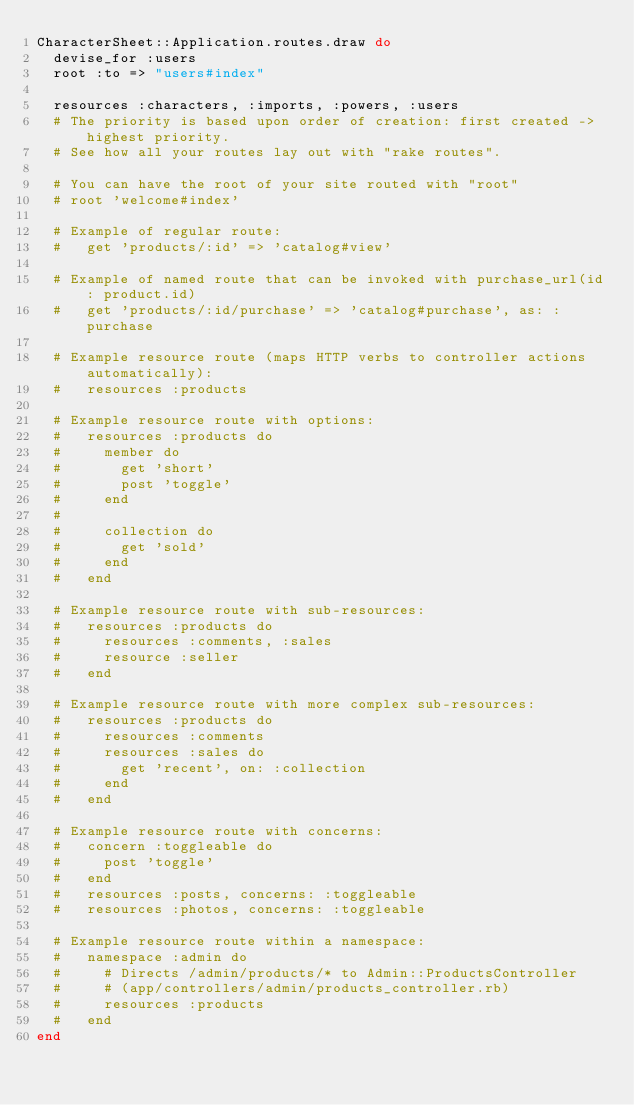Convert code to text. <code><loc_0><loc_0><loc_500><loc_500><_Ruby_>CharacterSheet::Application.routes.draw do
  devise_for :users
  root :to => "users#index"

  resources :characters, :imports, :powers, :users
  # The priority is based upon order of creation: first created -> highest priority.
  # See how all your routes lay out with "rake routes".

  # You can have the root of your site routed with "root"
  # root 'welcome#index'

  # Example of regular route:
  #   get 'products/:id' => 'catalog#view'

  # Example of named route that can be invoked with purchase_url(id: product.id)
  #   get 'products/:id/purchase' => 'catalog#purchase', as: :purchase

  # Example resource route (maps HTTP verbs to controller actions automatically):
  #   resources :products

  # Example resource route with options:
  #   resources :products do
  #     member do
  #       get 'short'
  #       post 'toggle'
  #     end
  #
  #     collection do
  #       get 'sold'
  #     end
  #   end

  # Example resource route with sub-resources:
  #   resources :products do
  #     resources :comments, :sales
  #     resource :seller
  #   end

  # Example resource route with more complex sub-resources:
  #   resources :products do
  #     resources :comments
  #     resources :sales do
  #       get 'recent', on: :collection
  #     end
  #   end

  # Example resource route with concerns:
  #   concern :toggleable do
  #     post 'toggle'
  #   end
  #   resources :posts, concerns: :toggleable
  #   resources :photos, concerns: :toggleable

  # Example resource route within a namespace:
  #   namespace :admin do
  #     # Directs /admin/products/* to Admin::ProductsController
  #     # (app/controllers/admin/products_controller.rb)
  #     resources :products
  #   end
end
</code> 